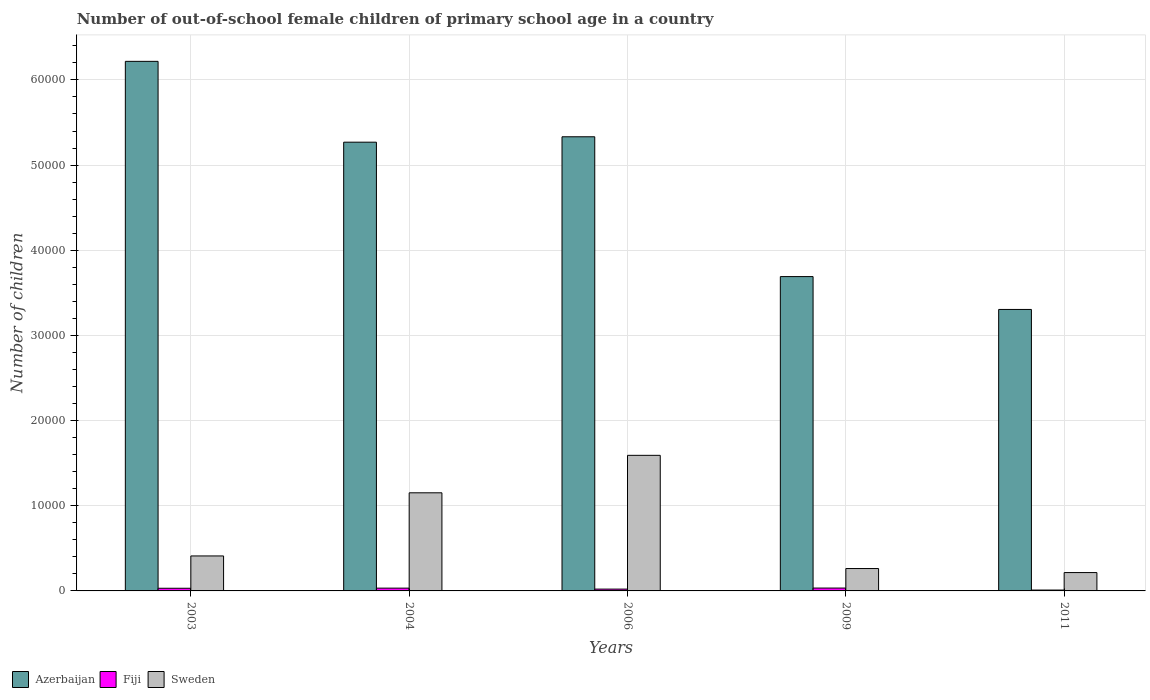How many different coloured bars are there?
Ensure brevity in your answer.  3. How many groups of bars are there?
Your response must be concise. 5. Are the number of bars on each tick of the X-axis equal?
Ensure brevity in your answer.  Yes. How many bars are there on the 3rd tick from the right?
Make the answer very short. 3. What is the label of the 2nd group of bars from the left?
Offer a terse response. 2004. In how many cases, is the number of bars for a given year not equal to the number of legend labels?
Your response must be concise. 0. What is the number of out-of-school female children in Fiji in 2004?
Ensure brevity in your answer.  327. Across all years, what is the maximum number of out-of-school female children in Sweden?
Provide a short and direct response. 1.59e+04. Across all years, what is the minimum number of out-of-school female children in Fiji?
Ensure brevity in your answer.  102. In which year was the number of out-of-school female children in Sweden minimum?
Your response must be concise. 2011. What is the total number of out-of-school female children in Azerbaijan in the graph?
Provide a succinct answer. 2.38e+05. What is the difference between the number of out-of-school female children in Fiji in 2004 and that in 2011?
Give a very brief answer. 225. What is the difference between the number of out-of-school female children in Sweden in 2011 and the number of out-of-school female children in Azerbaijan in 2006?
Make the answer very short. -5.12e+04. What is the average number of out-of-school female children in Sweden per year?
Your response must be concise. 7266.2. In the year 2003, what is the difference between the number of out-of-school female children in Fiji and number of out-of-school female children in Azerbaijan?
Provide a succinct answer. -6.19e+04. What is the ratio of the number of out-of-school female children in Sweden in 2003 to that in 2006?
Offer a very short reply. 0.26. Is the difference between the number of out-of-school female children in Fiji in 2003 and 2006 greater than the difference between the number of out-of-school female children in Azerbaijan in 2003 and 2006?
Your response must be concise. No. What is the difference between the highest and the second highest number of out-of-school female children in Sweden?
Offer a terse response. 4399. What is the difference between the highest and the lowest number of out-of-school female children in Fiji?
Ensure brevity in your answer.  235. Is the sum of the number of out-of-school female children in Azerbaijan in 2003 and 2009 greater than the maximum number of out-of-school female children in Sweden across all years?
Keep it short and to the point. Yes. What does the 1st bar from the left in 2009 represents?
Your response must be concise. Azerbaijan. What does the 2nd bar from the right in 2003 represents?
Your response must be concise. Fiji. Is it the case that in every year, the sum of the number of out-of-school female children in Azerbaijan and number of out-of-school female children in Fiji is greater than the number of out-of-school female children in Sweden?
Your response must be concise. Yes. Are the values on the major ticks of Y-axis written in scientific E-notation?
Ensure brevity in your answer.  No. Does the graph contain grids?
Your answer should be compact. Yes. How many legend labels are there?
Keep it short and to the point. 3. What is the title of the graph?
Provide a succinct answer. Number of out-of-school female children of primary school age in a country. What is the label or title of the X-axis?
Provide a succinct answer. Years. What is the label or title of the Y-axis?
Give a very brief answer. Number of children. What is the Number of children of Azerbaijan in 2003?
Make the answer very short. 6.22e+04. What is the Number of children of Fiji in 2003?
Your answer should be compact. 313. What is the Number of children in Sweden in 2003?
Your answer should be compact. 4107. What is the Number of children of Azerbaijan in 2004?
Ensure brevity in your answer.  5.27e+04. What is the Number of children of Fiji in 2004?
Provide a short and direct response. 327. What is the Number of children of Sweden in 2004?
Provide a succinct answer. 1.15e+04. What is the Number of children in Azerbaijan in 2006?
Ensure brevity in your answer.  5.33e+04. What is the Number of children in Fiji in 2006?
Keep it short and to the point. 213. What is the Number of children of Sweden in 2006?
Make the answer very short. 1.59e+04. What is the Number of children in Azerbaijan in 2009?
Make the answer very short. 3.69e+04. What is the Number of children in Fiji in 2009?
Keep it short and to the point. 337. What is the Number of children in Sweden in 2009?
Give a very brief answer. 2628. What is the Number of children in Azerbaijan in 2011?
Make the answer very short. 3.30e+04. What is the Number of children of Fiji in 2011?
Give a very brief answer. 102. What is the Number of children of Sweden in 2011?
Ensure brevity in your answer.  2155. Across all years, what is the maximum Number of children of Azerbaijan?
Your answer should be very brief. 6.22e+04. Across all years, what is the maximum Number of children of Fiji?
Provide a succinct answer. 337. Across all years, what is the maximum Number of children of Sweden?
Give a very brief answer. 1.59e+04. Across all years, what is the minimum Number of children in Azerbaijan?
Your response must be concise. 3.30e+04. Across all years, what is the minimum Number of children of Fiji?
Provide a succinct answer. 102. Across all years, what is the minimum Number of children in Sweden?
Your answer should be very brief. 2155. What is the total Number of children of Azerbaijan in the graph?
Your response must be concise. 2.38e+05. What is the total Number of children in Fiji in the graph?
Your answer should be compact. 1292. What is the total Number of children of Sweden in the graph?
Ensure brevity in your answer.  3.63e+04. What is the difference between the Number of children in Azerbaijan in 2003 and that in 2004?
Your answer should be very brief. 9490. What is the difference between the Number of children in Sweden in 2003 and that in 2004?
Provide a short and direct response. -7414. What is the difference between the Number of children in Azerbaijan in 2003 and that in 2006?
Ensure brevity in your answer.  8856. What is the difference between the Number of children in Sweden in 2003 and that in 2006?
Ensure brevity in your answer.  -1.18e+04. What is the difference between the Number of children in Azerbaijan in 2003 and that in 2009?
Provide a short and direct response. 2.53e+04. What is the difference between the Number of children of Fiji in 2003 and that in 2009?
Ensure brevity in your answer.  -24. What is the difference between the Number of children of Sweden in 2003 and that in 2009?
Ensure brevity in your answer.  1479. What is the difference between the Number of children in Azerbaijan in 2003 and that in 2011?
Provide a succinct answer. 2.91e+04. What is the difference between the Number of children of Fiji in 2003 and that in 2011?
Offer a terse response. 211. What is the difference between the Number of children of Sweden in 2003 and that in 2011?
Give a very brief answer. 1952. What is the difference between the Number of children in Azerbaijan in 2004 and that in 2006?
Give a very brief answer. -634. What is the difference between the Number of children of Fiji in 2004 and that in 2006?
Your response must be concise. 114. What is the difference between the Number of children of Sweden in 2004 and that in 2006?
Provide a succinct answer. -4399. What is the difference between the Number of children of Azerbaijan in 2004 and that in 2009?
Keep it short and to the point. 1.58e+04. What is the difference between the Number of children of Fiji in 2004 and that in 2009?
Offer a very short reply. -10. What is the difference between the Number of children of Sweden in 2004 and that in 2009?
Your answer should be compact. 8893. What is the difference between the Number of children in Azerbaijan in 2004 and that in 2011?
Your response must be concise. 1.96e+04. What is the difference between the Number of children of Fiji in 2004 and that in 2011?
Offer a terse response. 225. What is the difference between the Number of children in Sweden in 2004 and that in 2011?
Keep it short and to the point. 9366. What is the difference between the Number of children in Azerbaijan in 2006 and that in 2009?
Make the answer very short. 1.64e+04. What is the difference between the Number of children of Fiji in 2006 and that in 2009?
Ensure brevity in your answer.  -124. What is the difference between the Number of children of Sweden in 2006 and that in 2009?
Provide a succinct answer. 1.33e+04. What is the difference between the Number of children in Azerbaijan in 2006 and that in 2011?
Your answer should be very brief. 2.03e+04. What is the difference between the Number of children in Fiji in 2006 and that in 2011?
Offer a very short reply. 111. What is the difference between the Number of children of Sweden in 2006 and that in 2011?
Offer a terse response. 1.38e+04. What is the difference between the Number of children in Azerbaijan in 2009 and that in 2011?
Your answer should be very brief. 3857. What is the difference between the Number of children in Fiji in 2009 and that in 2011?
Your answer should be compact. 235. What is the difference between the Number of children of Sweden in 2009 and that in 2011?
Your answer should be compact. 473. What is the difference between the Number of children of Azerbaijan in 2003 and the Number of children of Fiji in 2004?
Your response must be concise. 6.19e+04. What is the difference between the Number of children in Azerbaijan in 2003 and the Number of children in Sweden in 2004?
Make the answer very short. 5.07e+04. What is the difference between the Number of children of Fiji in 2003 and the Number of children of Sweden in 2004?
Provide a short and direct response. -1.12e+04. What is the difference between the Number of children in Azerbaijan in 2003 and the Number of children in Fiji in 2006?
Provide a succinct answer. 6.20e+04. What is the difference between the Number of children in Azerbaijan in 2003 and the Number of children in Sweden in 2006?
Provide a short and direct response. 4.63e+04. What is the difference between the Number of children of Fiji in 2003 and the Number of children of Sweden in 2006?
Your answer should be very brief. -1.56e+04. What is the difference between the Number of children of Azerbaijan in 2003 and the Number of children of Fiji in 2009?
Ensure brevity in your answer.  6.18e+04. What is the difference between the Number of children of Azerbaijan in 2003 and the Number of children of Sweden in 2009?
Provide a succinct answer. 5.96e+04. What is the difference between the Number of children in Fiji in 2003 and the Number of children in Sweden in 2009?
Keep it short and to the point. -2315. What is the difference between the Number of children of Azerbaijan in 2003 and the Number of children of Fiji in 2011?
Provide a succinct answer. 6.21e+04. What is the difference between the Number of children in Azerbaijan in 2003 and the Number of children in Sweden in 2011?
Your answer should be very brief. 6.00e+04. What is the difference between the Number of children in Fiji in 2003 and the Number of children in Sweden in 2011?
Make the answer very short. -1842. What is the difference between the Number of children in Azerbaijan in 2004 and the Number of children in Fiji in 2006?
Keep it short and to the point. 5.25e+04. What is the difference between the Number of children of Azerbaijan in 2004 and the Number of children of Sweden in 2006?
Make the answer very short. 3.68e+04. What is the difference between the Number of children of Fiji in 2004 and the Number of children of Sweden in 2006?
Offer a very short reply. -1.56e+04. What is the difference between the Number of children in Azerbaijan in 2004 and the Number of children in Fiji in 2009?
Ensure brevity in your answer.  5.24e+04. What is the difference between the Number of children of Azerbaijan in 2004 and the Number of children of Sweden in 2009?
Provide a succinct answer. 5.01e+04. What is the difference between the Number of children of Fiji in 2004 and the Number of children of Sweden in 2009?
Provide a short and direct response. -2301. What is the difference between the Number of children of Azerbaijan in 2004 and the Number of children of Fiji in 2011?
Provide a succinct answer. 5.26e+04. What is the difference between the Number of children of Azerbaijan in 2004 and the Number of children of Sweden in 2011?
Give a very brief answer. 5.05e+04. What is the difference between the Number of children of Fiji in 2004 and the Number of children of Sweden in 2011?
Provide a succinct answer. -1828. What is the difference between the Number of children of Azerbaijan in 2006 and the Number of children of Fiji in 2009?
Your response must be concise. 5.30e+04. What is the difference between the Number of children in Azerbaijan in 2006 and the Number of children in Sweden in 2009?
Your answer should be compact. 5.07e+04. What is the difference between the Number of children in Fiji in 2006 and the Number of children in Sweden in 2009?
Provide a short and direct response. -2415. What is the difference between the Number of children of Azerbaijan in 2006 and the Number of children of Fiji in 2011?
Provide a short and direct response. 5.32e+04. What is the difference between the Number of children of Azerbaijan in 2006 and the Number of children of Sweden in 2011?
Ensure brevity in your answer.  5.12e+04. What is the difference between the Number of children of Fiji in 2006 and the Number of children of Sweden in 2011?
Provide a short and direct response. -1942. What is the difference between the Number of children of Azerbaijan in 2009 and the Number of children of Fiji in 2011?
Provide a succinct answer. 3.68e+04. What is the difference between the Number of children of Azerbaijan in 2009 and the Number of children of Sweden in 2011?
Ensure brevity in your answer.  3.48e+04. What is the difference between the Number of children of Fiji in 2009 and the Number of children of Sweden in 2011?
Offer a very short reply. -1818. What is the average Number of children in Azerbaijan per year?
Offer a terse response. 4.76e+04. What is the average Number of children of Fiji per year?
Your answer should be very brief. 258.4. What is the average Number of children of Sweden per year?
Offer a very short reply. 7266.2. In the year 2003, what is the difference between the Number of children in Azerbaijan and Number of children in Fiji?
Make the answer very short. 6.19e+04. In the year 2003, what is the difference between the Number of children in Azerbaijan and Number of children in Sweden?
Your response must be concise. 5.81e+04. In the year 2003, what is the difference between the Number of children of Fiji and Number of children of Sweden?
Ensure brevity in your answer.  -3794. In the year 2004, what is the difference between the Number of children of Azerbaijan and Number of children of Fiji?
Your answer should be compact. 5.24e+04. In the year 2004, what is the difference between the Number of children of Azerbaijan and Number of children of Sweden?
Your response must be concise. 4.12e+04. In the year 2004, what is the difference between the Number of children of Fiji and Number of children of Sweden?
Your answer should be compact. -1.12e+04. In the year 2006, what is the difference between the Number of children of Azerbaijan and Number of children of Fiji?
Ensure brevity in your answer.  5.31e+04. In the year 2006, what is the difference between the Number of children in Azerbaijan and Number of children in Sweden?
Keep it short and to the point. 3.74e+04. In the year 2006, what is the difference between the Number of children of Fiji and Number of children of Sweden?
Ensure brevity in your answer.  -1.57e+04. In the year 2009, what is the difference between the Number of children of Azerbaijan and Number of children of Fiji?
Give a very brief answer. 3.66e+04. In the year 2009, what is the difference between the Number of children in Azerbaijan and Number of children in Sweden?
Provide a succinct answer. 3.43e+04. In the year 2009, what is the difference between the Number of children of Fiji and Number of children of Sweden?
Your response must be concise. -2291. In the year 2011, what is the difference between the Number of children in Azerbaijan and Number of children in Fiji?
Your answer should be very brief. 3.29e+04. In the year 2011, what is the difference between the Number of children in Azerbaijan and Number of children in Sweden?
Keep it short and to the point. 3.09e+04. In the year 2011, what is the difference between the Number of children of Fiji and Number of children of Sweden?
Offer a very short reply. -2053. What is the ratio of the Number of children in Azerbaijan in 2003 to that in 2004?
Offer a terse response. 1.18. What is the ratio of the Number of children of Fiji in 2003 to that in 2004?
Make the answer very short. 0.96. What is the ratio of the Number of children in Sweden in 2003 to that in 2004?
Offer a terse response. 0.36. What is the ratio of the Number of children of Azerbaijan in 2003 to that in 2006?
Your response must be concise. 1.17. What is the ratio of the Number of children in Fiji in 2003 to that in 2006?
Make the answer very short. 1.47. What is the ratio of the Number of children of Sweden in 2003 to that in 2006?
Your answer should be very brief. 0.26. What is the ratio of the Number of children in Azerbaijan in 2003 to that in 2009?
Provide a short and direct response. 1.68. What is the ratio of the Number of children of Fiji in 2003 to that in 2009?
Keep it short and to the point. 0.93. What is the ratio of the Number of children in Sweden in 2003 to that in 2009?
Make the answer very short. 1.56. What is the ratio of the Number of children of Azerbaijan in 2003 to that in 2011?
Offer a terse response. 1.88. What is the ratio of the Number of children in Fiji in 2003 to that in 2011?
Make the answer very short. 3.07. What is the ratio of the Number of children in Sweden in 2003 to that in 2011?
Your response must be concise. 1.91. What is the ratio of the Number of children of Fiji in 2004 to that in 2006?
Provide a short and direct response. 1.54. What is the ratio of the Number of children of Sweden in 2004 to that in 2006?
Your response must be concise. 0.72. What is the ratio of the Number of children in Azerbaijan in 2004 to that in 2009?
Keep it short and to the point. 1.43. What is the ratio of the Number of children of Fiji in 2004 to that in 2009?
Offer a very short reply. 0.97. What is the ratio of the Number of children of Sweden in 2004 to that in 2009?
Your response must be concise. 4.38. What is the ratio of the Number of children in Azerbaijan in 2004 to that in 2011?
Keep it short and to the point. 1.59. What is the ratio of the Number of children in Fiji in 2004 to that in 2011?
Your answer should be compact. 3.21. What is the ratio of the Number of children in Sweden in 2004 to that in 2011?
Provide a succinct answer. 5.35. What is the ratio of the Number of children in Azerbaijan in 2006 to that in 2009?
Provide a short and direct response. 1.44. What is the ratio of the Number of children in Fiji in 2006 to that in 2009?
Your answer should be compact. 0.63. What is the ratio of the Number of children of Sweden in 2006 to that in 2009?
Provide a succinct answer. 6.06. What is the ratio of the Number of children of Azerbaijan in 2006 to that in 2011?
Ensure brevity in your answer.  1.61. What is the ratio of the Number of children of Fiji in 2006 to that in 2011?
Provide a succinct answer. 2.09. What is the ratio of the Number of children in Sweden in 2006 to that in 2011?
Your answer should be compact. 7.39. What is the ratio of the Number of children in Azerbaijan in 2009 to that in 2011?
Keep it short and to the point. 1.12. What is the ratio of the Number of children of Fiji in 2009 to that in 2011?
Keep it short and to the point. 3.3. What is the ratio of the Number of children of Sweden in 2009 to that in 2011?
Provide a succinct answer. 1.22. What is the difference between the highest and the second highest Number of children of Azerbaijan?
Keep it short and to the point. 8856. What is the difference between the highest and the second highest Number of children of Sweden?
Provide a succinct answer. 4399. What is the difference between the highest and the lowest Number of children in Azerbaijan?
Offer a very short reply. 2.91e+04. What is the difference between the highest and the lowest Number of children in Fiji?
Your answer should be very brief. 235. What is the difference between the highest and the lowest Number of children of Sweden?
Make the answer very short. 1.38e+04. 